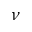<formula> <loc_0><loc_0><loc_500><loc_500>\nu</formula> 